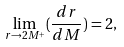<formula> <loc_0><loc_0><loc_500><loc_500>\lim _ { r \rightarrow 2 M ^ { + } } ( \frac { d r } { d M } ) = 2 ,</formula> 